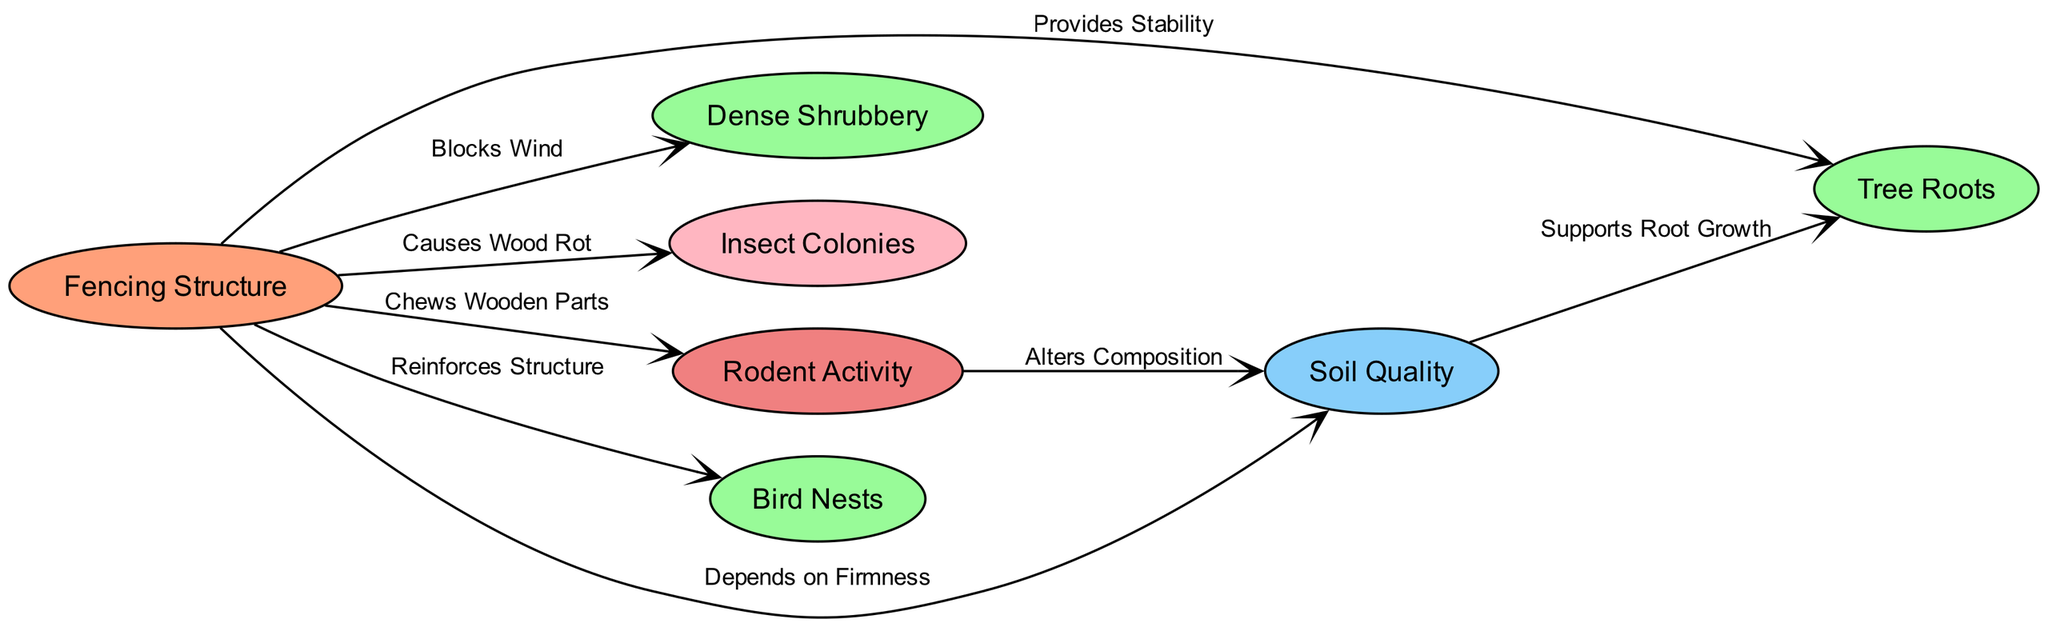What is the central node of the diagram? The central node is identified by its type "central," which represents the main topic of the diagram. By looking at the node definitions, we can see that the node labeled "Fencing Structure" has the type "central."
Answer: Fencing Structure How many support nodes are in the diagram? The support nodes are categorized under the type "support." By reviewing the node list, there are three nodes labeled as "Tree Roots," "Dense Shrubbery," and "Bird Nests." Counting these gives a total of three support nodes.
Answer: 3 What does the "Tree Roots" node provide to the "Fencing Structure"? The "Tree Roots" node has a directed edge from it to the "Fencing Structure" node, labeled as "Provides Stability." Thus, it indicates a supportive relationship.
Answer: Provides Stability Which type of activity is linked to causing wood degradation in the "Fencing Structure"? The "Insect Colonies" node is associated with the "Fencing Structure," connected with an edge labeled "Causes Wood Rot," indicating that insect activity contributes to wood degradation.
Answer: Insect Colonies What relationship exists between the "Rodent Activity" and "Soil Quality"? There is a directed edge from "Rodent Activity" to "Soil Quality," labeled as "Alters Composition." This implies that rodent activities have an effect on the composition of the soil quality, thus linking them together.
Answer: Alters Composition Which node reinforces the "Fencing Structure"? The directed edge from the "Bird Nests" node to the "Fencing Structure" is labeled "Reinforces Structure," indicating that the presence of bird nests provides structural reinforcement to the fencing.
Answer: Bird Nests How does "Soil Quality" impact "Tree Roots"? The "Soil Quality" node has a directed edge labeled "Supports Root Growth" pointing to the "Tree Roots" node. This indicates that improved soil quality facilitates the growth of tree roots.
Answer: Supports Root Growth What effect does the "Rodent Activity" have on the "Fencing Structure"? "Rodent Activity" has a directed edge to the "Fencing Structure," labeled "Chews Wooden Parts," showing that this activity can directly damage the fencing structure itself.
Answer: Chews Wooden Parts What environmental factor is mentioned in relation to the "Fencing Structure"? The "Soil Quality" node is linked to the "Fencing Structure" with the label "Depends on Firmness." Therefore, soil quality is identified as an environmental factor that affects the fencing integrity.
Answer: Depends on Firmness 